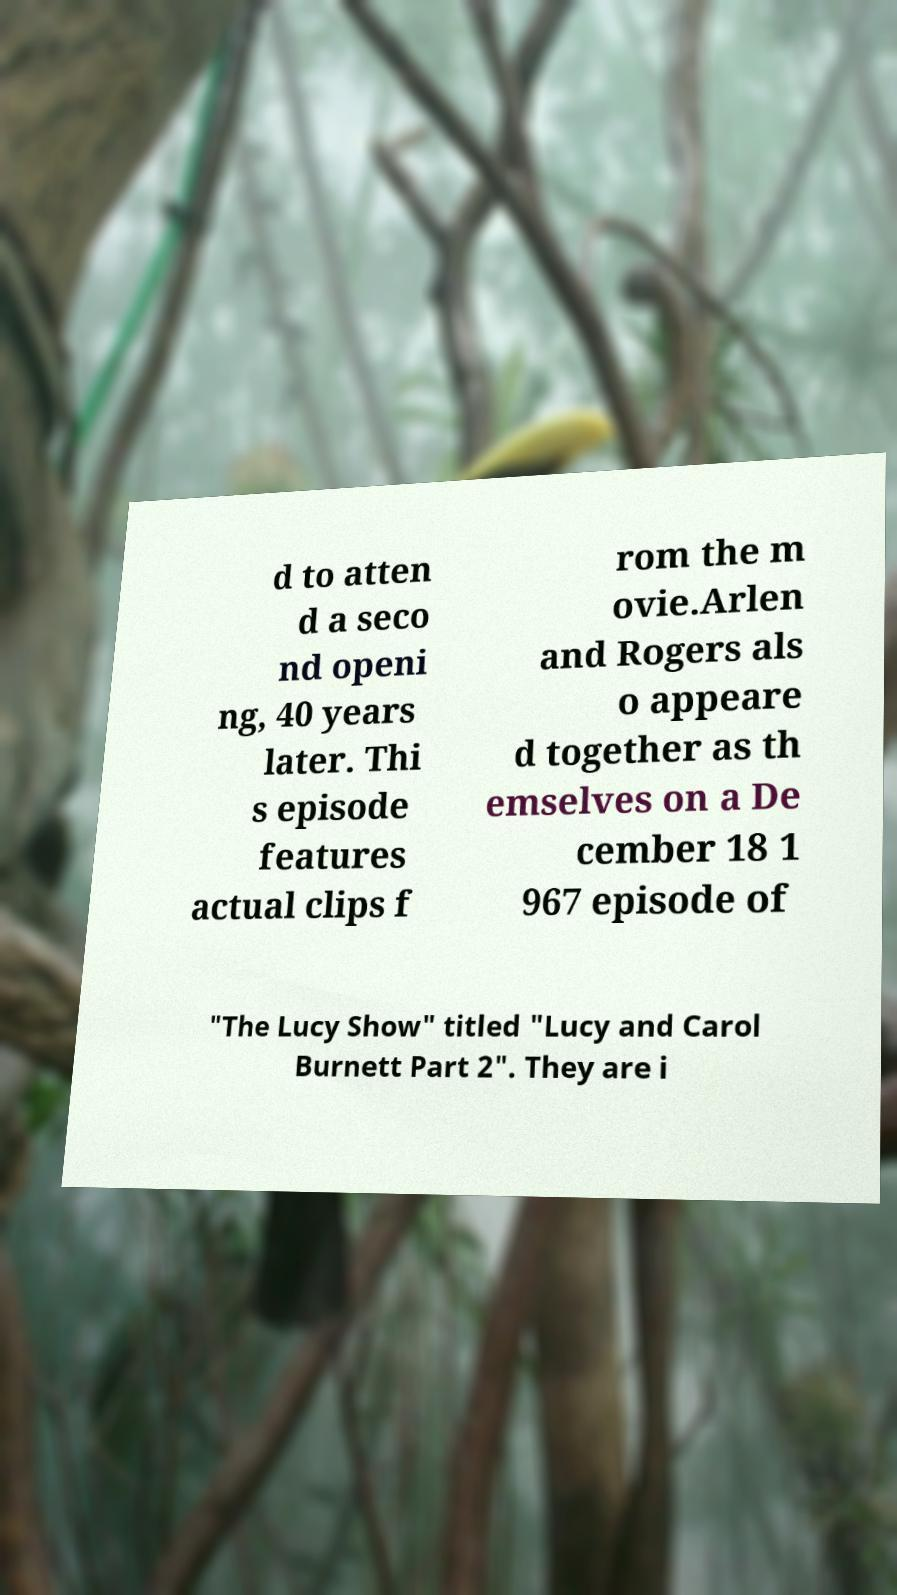I need the written content from this picture converted into text. Can you do that? d to atten d a seco nd openi ng, 40 years later. Thi s episode features actual clips f rom the m ovie.Arlen and Rogers als o appeare d together as th emselves on a De cember 18 1 967 episode of "The Lucy Show" titled "Lucy and Carol Burnett Part 2". They are i 